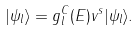Convert formula to latex. <formula><loc_0><loc_0><loc_500><loc_500>| \psi _ { l } \rangle = g _ { l } ^ { C } ( E ) v ^ { s } | \psi _ { l } \rangle .</formula> 